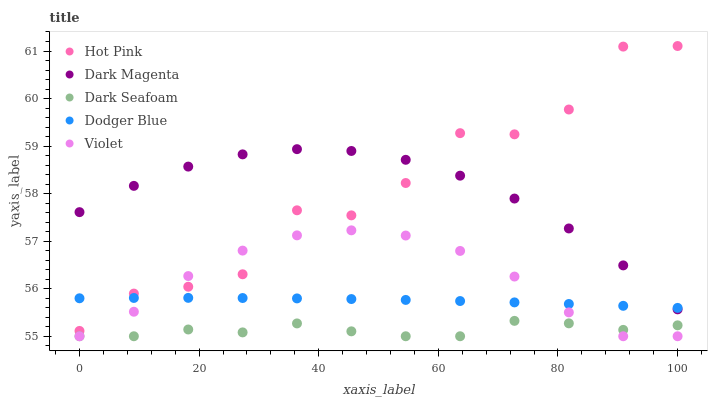Does Dark Seafoam have the minimum area under the curve?
Answer yes or no. Yes. Does Hot Pink have the maximum area under the curve?
Answer yes or no. Yes. Does Dodger Blue have the minimum area under the curve?
Answer yes or no. No. Does Dodger Blue have the maximum area under the curve?
Answer yes or no. No. Is Dodger Blue the smoothest?
Answer yes or no. Yes. Is Hot Pink the roughest?
Answer yes or no. Yes. Is Hot Pink the smoothest?
Answer yes or no. No. Is Dodger Blue the roughest?
Answer yes or no. No. Does Dark Seafoam have the lowest value?
Answer yes or no. Yes. Does Hot Pink have the lowest value?
Answer yes or no. No. Does Hot Pink have the highest value?
Answer yes or no. Yes. Does Dodger Blue have the highest value?
Answer yes or no. No. Is Violet less than Dark Magenta?
Answer yes or no. Yes. Is Dark Magenta greater than Violet?
Answer yes or no. Yes. Does Violet intersect Dark Seafoam?
Answer yes or no. Yes. Is Violet less than Dark Seafoam?
Answer yes or no. No. Is Violet greater than Dark Seafoam?
Answer yes or no. No. Does Violet intersect Dark Magenta?
Answer yes or no. No. 